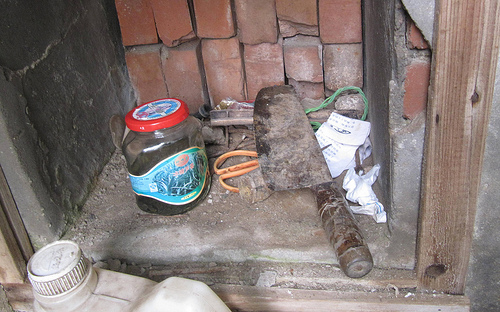<image>
Can you confirm if the scissors is under the knife? Yes. The scissors is positioned underneath the knife, with the knife above it in the vertical space. Is the jar to the right of the knife? No. The jar is not to the right of the knife. The horizontal positioning shows a different relationship. Is there a jar next to the knife? Yes. The jar is positioned adjacent to the knife, located nearby in the same general area. 